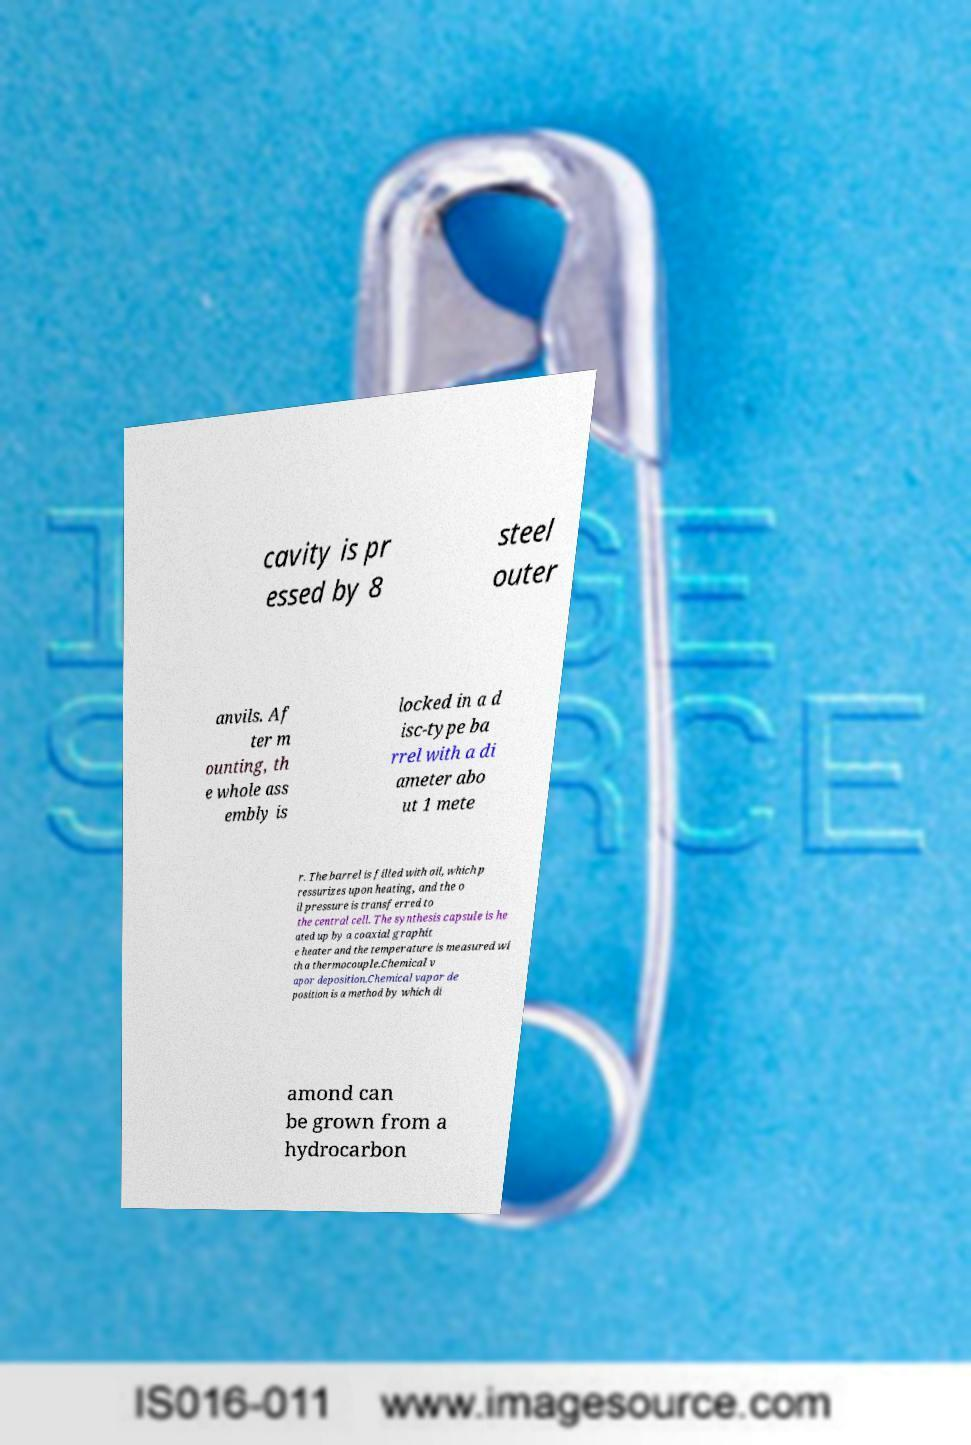There's text embedded in this image that I need extracted. Can you transcribe it verbatim? cavity is pr essed by 8 steel outer anvils. Af ter m ounting, th e whole ass embly is locked in a d isc-type ba rrel with a di ameter abo ut 1 mete r. The barrel is filled with oil, which p ressurizes upon heating, and the o il pressure is transferred to the central cell. The synthesis capsule is he ated up by a coaxial graphit e heater and the temperature is measured wi th a thermocouple.Chemical v apor deposition.Chemical vapor de position is a method by which di amond can be grown from a hydrocarbon 